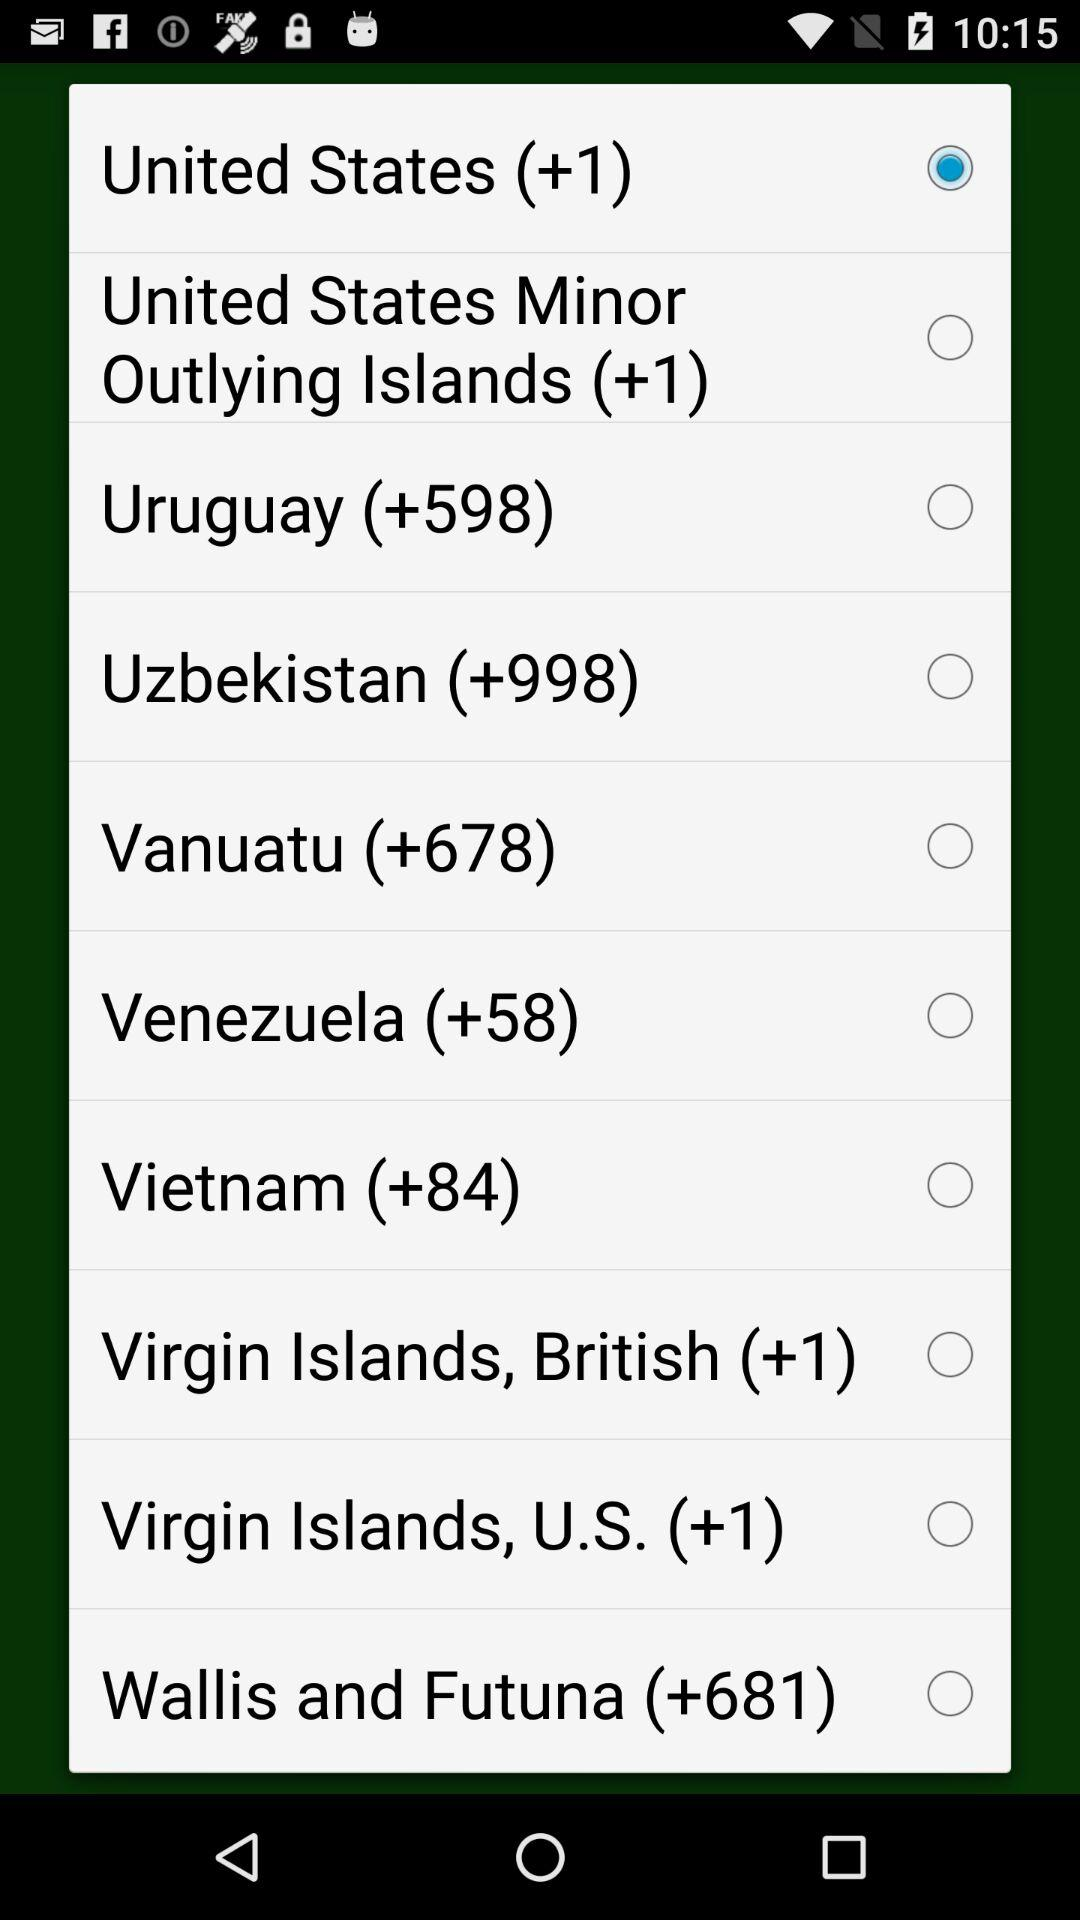What is Uzbekistan's country code? Uzbekistan's country code is +998. 